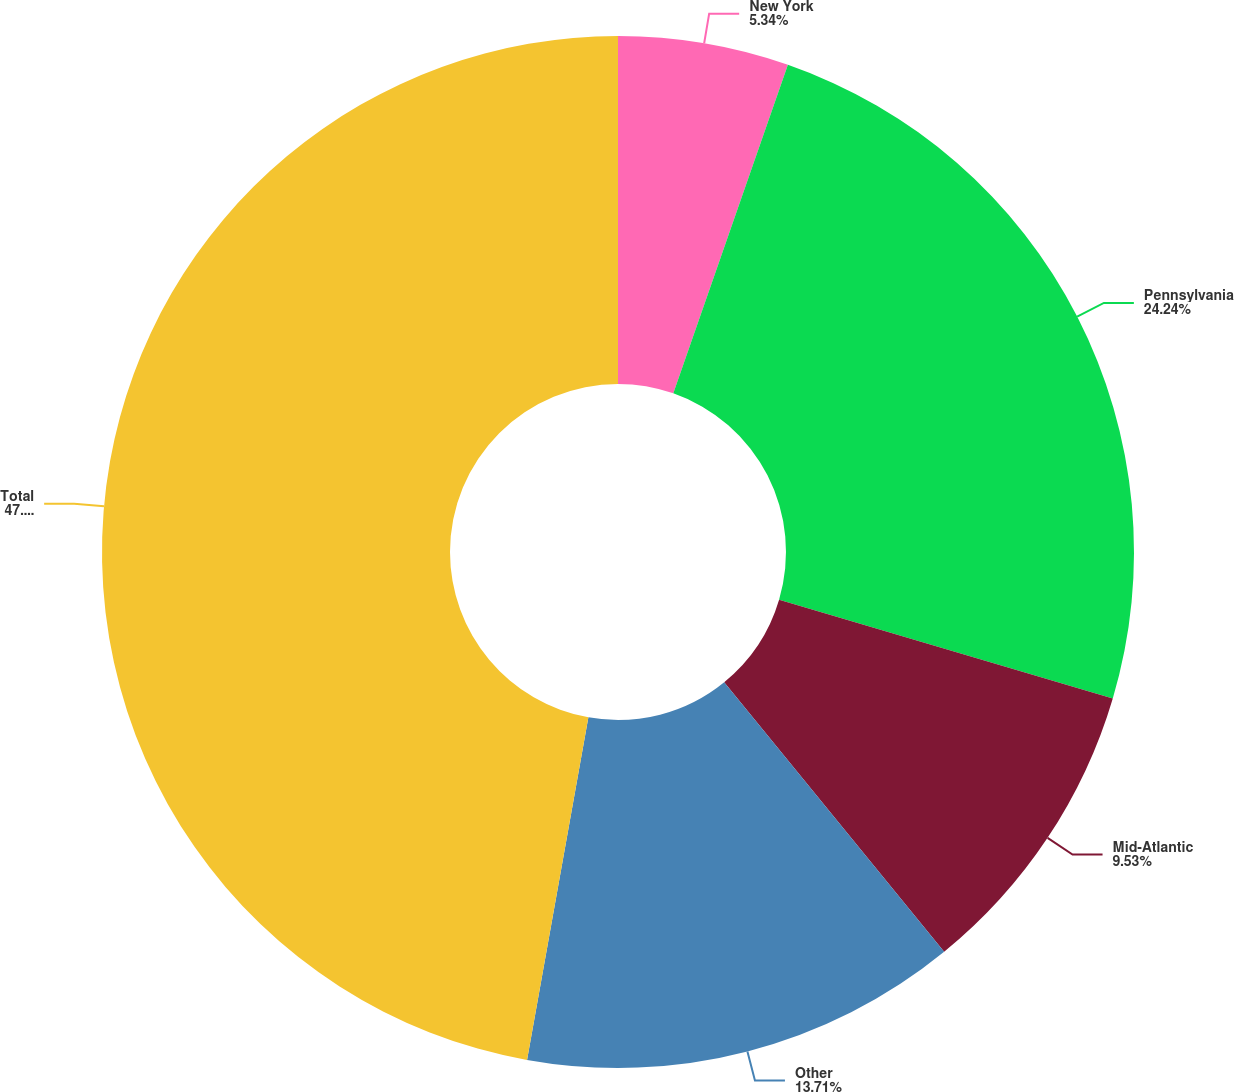Convert chart to OTSL. <chart><loc_0><loc_0><loc_500><loc_500><pie_chart><fcel>New York<fcel>Pennsylvania<fcel>Mid-Atlantic<fcel>Other<fcel>Total<nl><fcel>5.34%<fcel>24.24%<fcel>9.53%<fcel>13.71%<fcel>47.18%<nl></chart> 